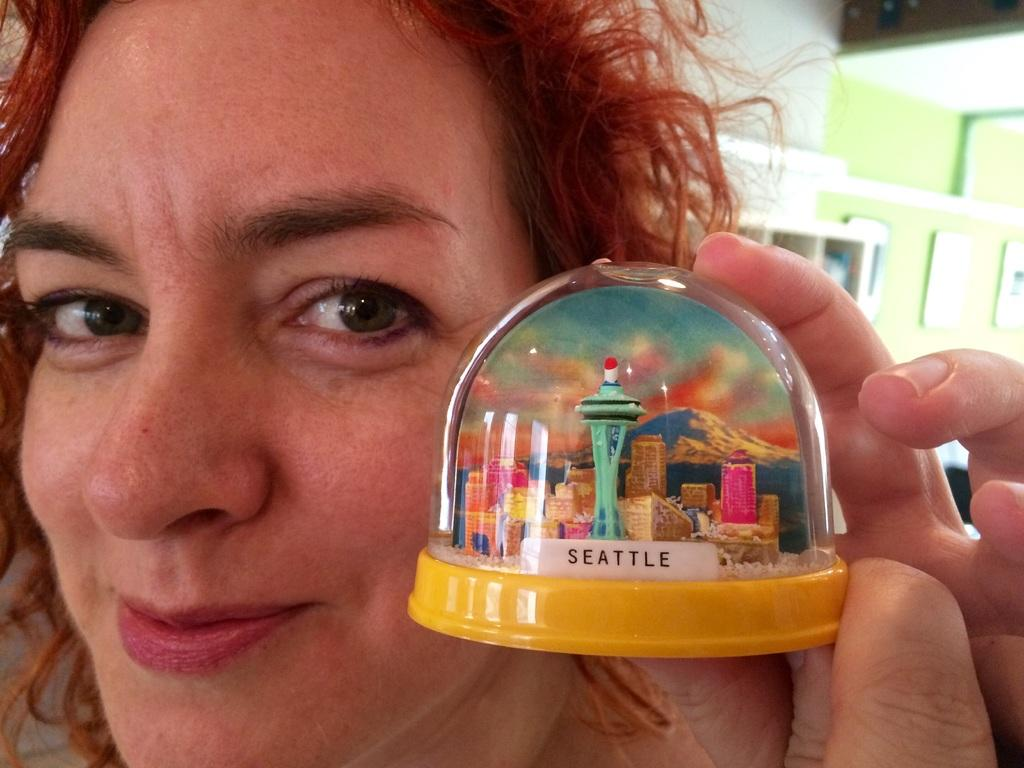<image>
Relay a brief, clear account of the picture shown. Woman holding a snow globe that says Seattle on it. 